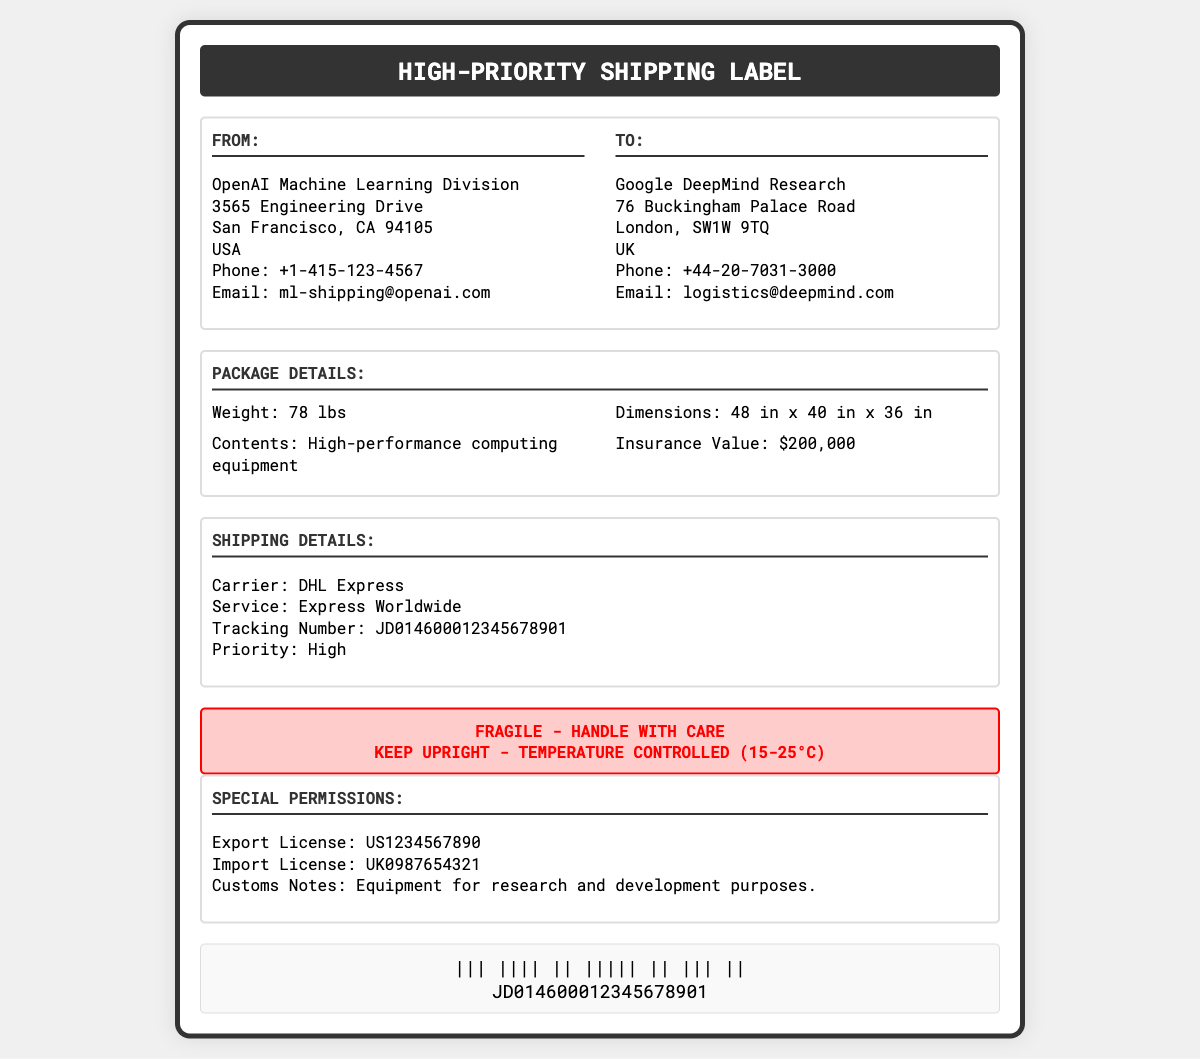what is the weight of the package? The weight of the package is stated directly in the package details section.
Answer: 78 lbs who is the sender of the package? The sender is identified in the "FROM" section of the document.
Answer: OpenAI Machine Learning Division what is the insurance value of the package? The insurance value is mentioned in the package details section, representing the value covered in case of loss or damage.
Answer: $200,000 which carrier is used for shipping? The carrier's name can be found in the "SHIPPING DETAILS" section of the document.
Answer: DHL Express what is the priority type for this shipment? The priority type is specified in the "SHIPPING DETAILS" section regarding the urgency of the delivery.
Answer: High what are the provided contact details for the recipient? The contact details for the recipient can be found in the "TO" section.
Answer: Phone: +44-20-7031-3000, Email: logistics@deepmind.com what special notice is mentioned regarding the handling of the package? The special notice can be found in the warning section, highlighting important handling instructions.
Answer: FRAGILE - HANDLE WITH CARE what are the dimensions of the package? The dimensions are specified clearly in the package details section.
Answer: 48 in x 40 in x 36 in what is the import license number? The import license number is included in the special permissions section of the document.
Answer: UK0987654321 what is the contents of the package? The contents of the package are listed in the package details section.
Answer: High-performance computing equipment 